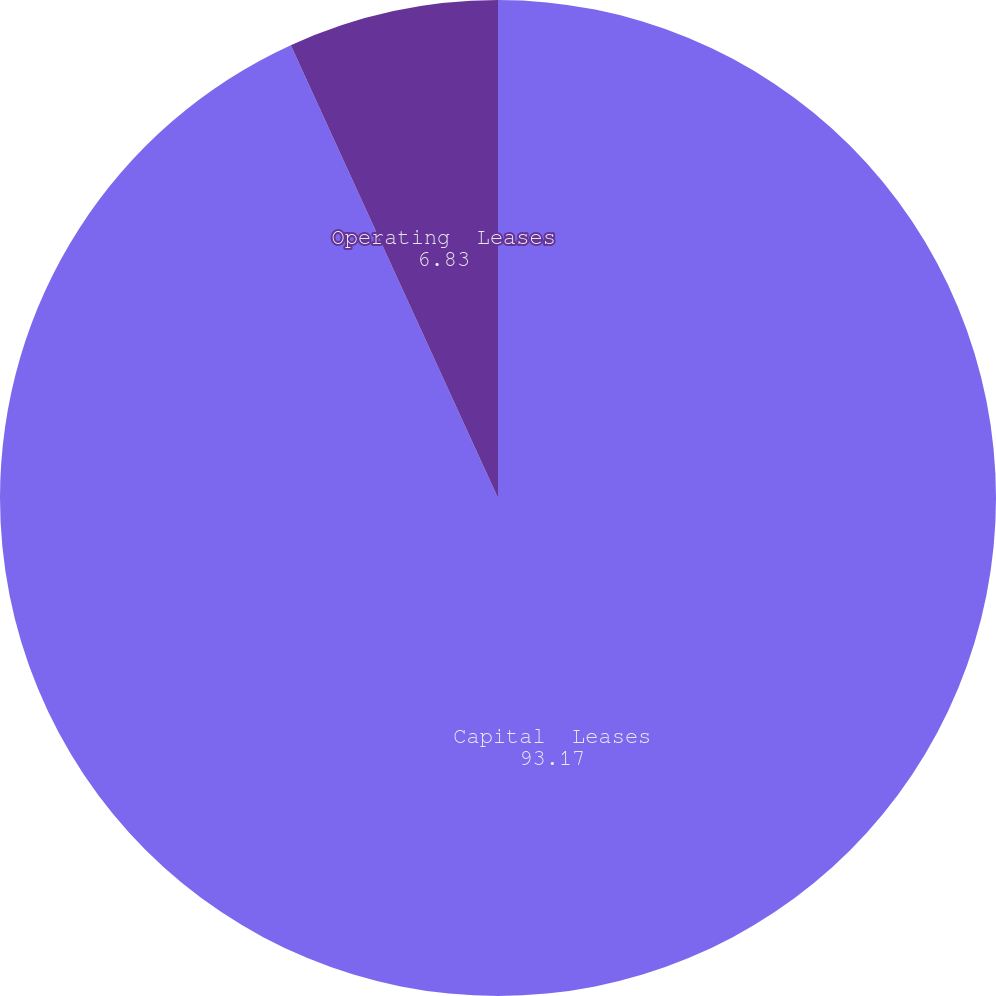Convert chart to OTSL. <chart><loc_0><loc_0><loc_500><loc_500><pie_chart><fcel>Capital  Leases<fcel>Operating  Leases<nl><fcel>93.17%<fcel>6.83%<nl></chart> 